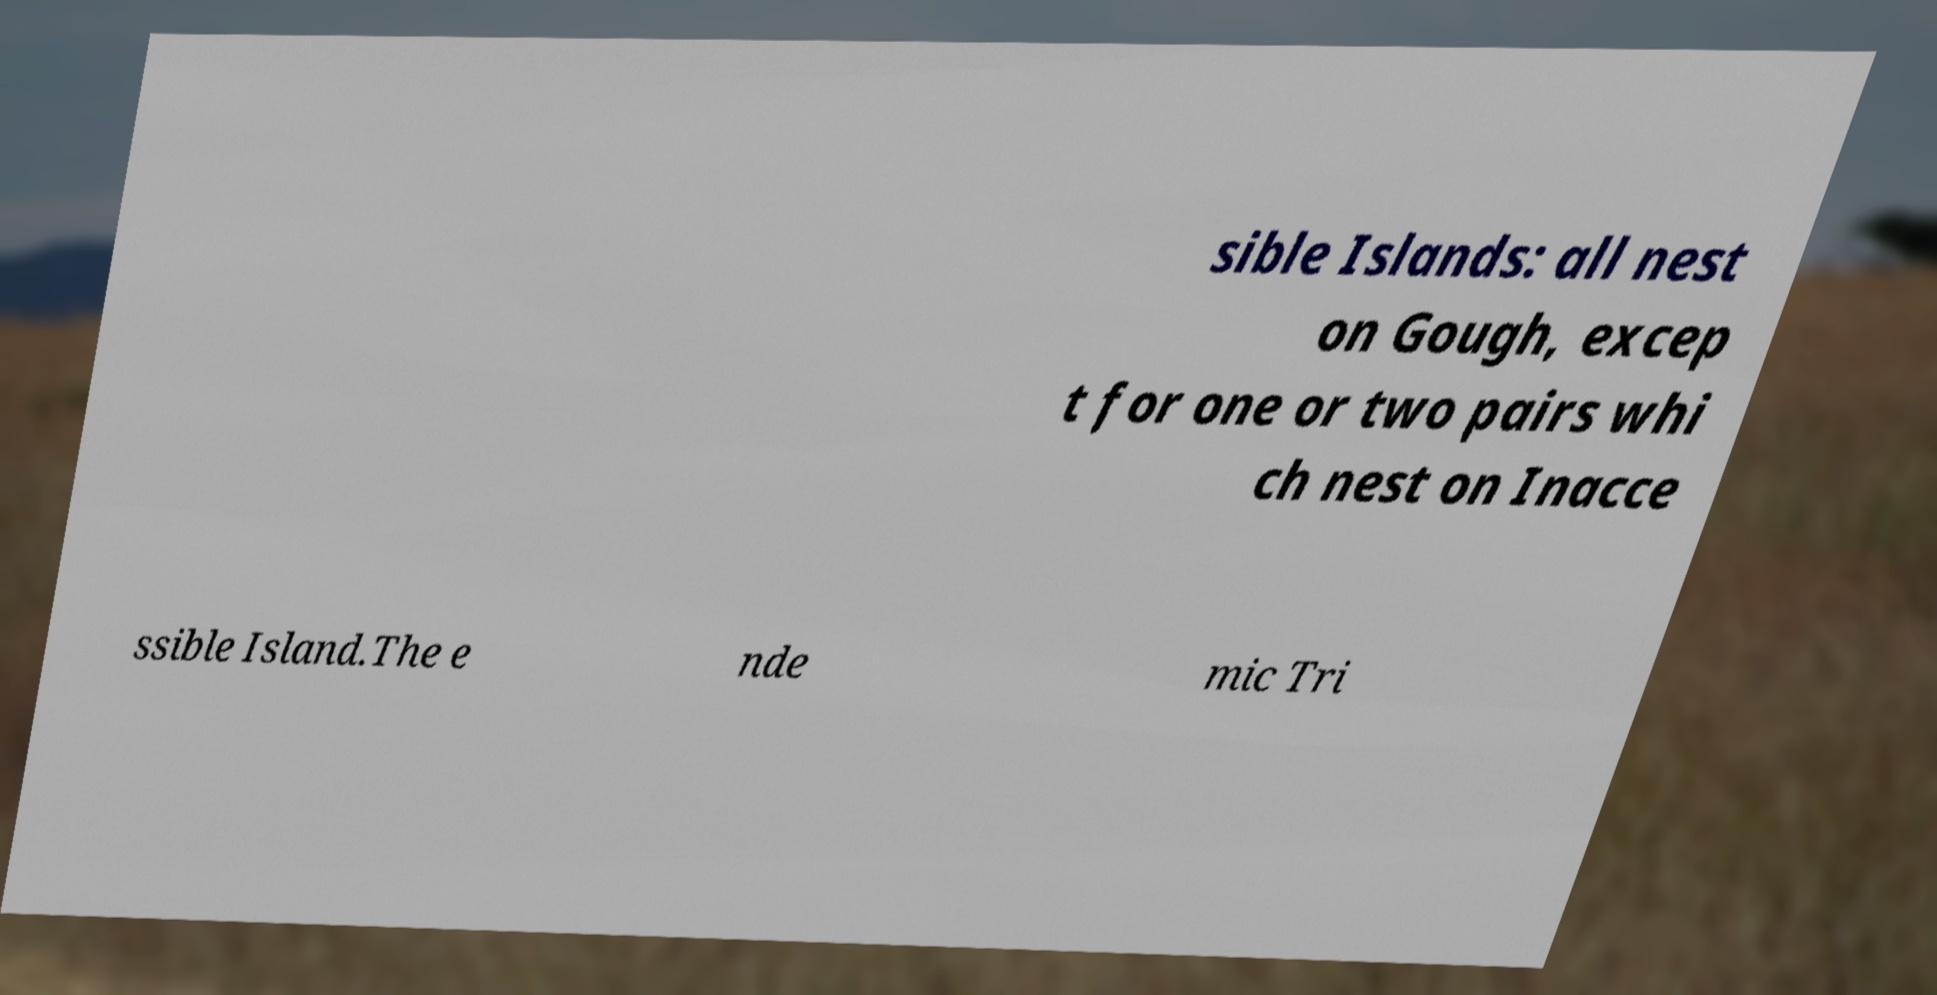What messages or text are displayed in this image? I need them in a readable, typed format. sible Islands: all nest on Gough, excep t for one or two pairs whi ch nest on Inacce ssible Island.The e nde mic Tri 